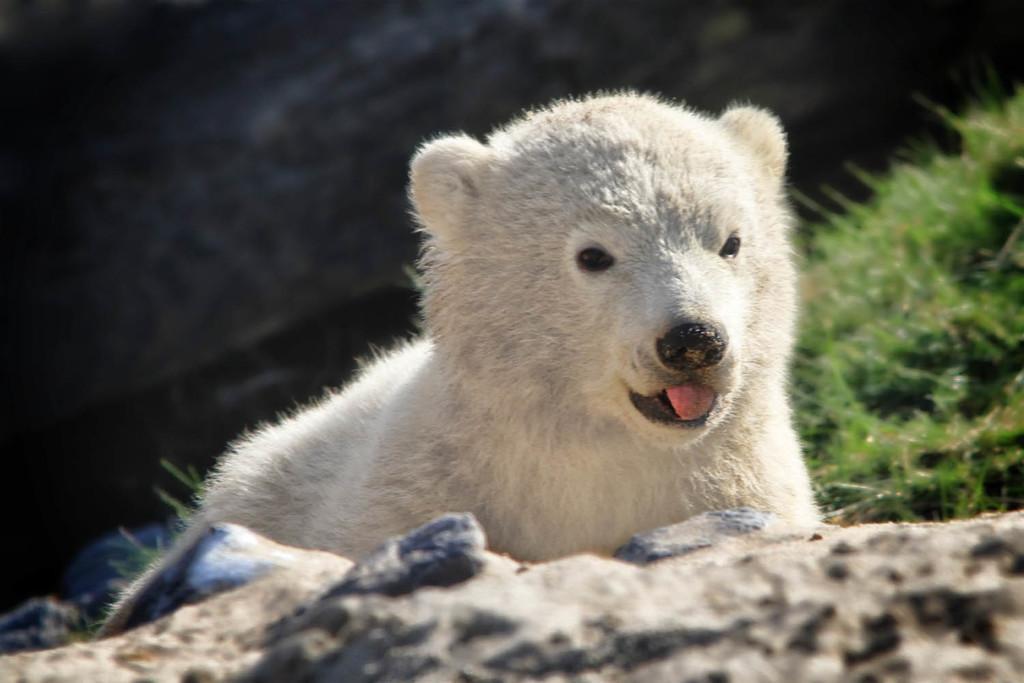Can you describe this image briefly? In this image, I can see a polar bear. At the bottom of the image, there are rocks. On the right side of the image, I can see the grass. There is a blurred background. 